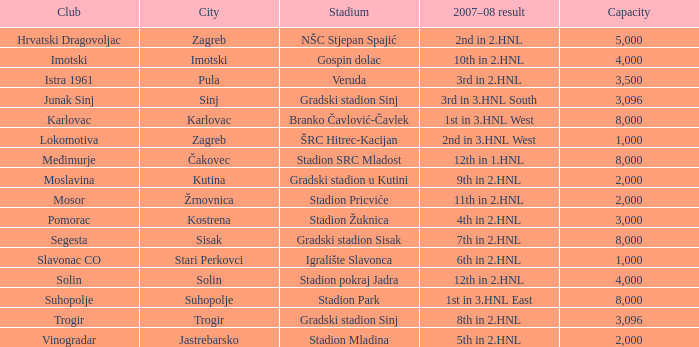What is the lowest capacity that has stadion mladina as the stadium? 2000.0. 